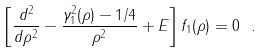Convert formula to latex. <formula><loc_0><loc_0><loc_500><loc_500>\left [ \frac { d ^ { 2 } } { d \rho ^ { 2 } } - \frac { \gamma _ { 1 } ^ { 2 } ( \rho ) - 1 / 4 } { \rho ^ { 2 } } + E \right ] f _ { 1 } ( \rho ) = 0 \ .</formula> 